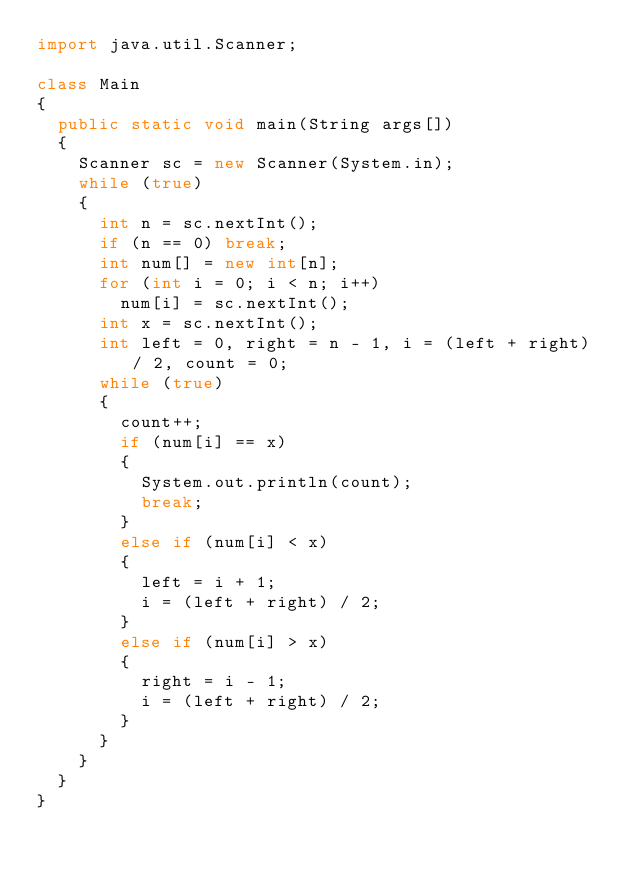<code> <loc_0><loc_0><loc_500><loc_500><_Java_>import java.util.Scanner;

class Main
{
	public static void main(String args[])
	{
		Scanner sc = new Scanner(System.in);
		while (true)
		{
			int n = sc.nextInt();
			if (n == 0) break;
			int num[] = new int[n];
			for (int i = 0; i < n; i++)
				num[i] = sc.nextInt();
			int x = sc.nextInt();
			int left = 0, right = n - 1, i = (left + right) / 2, count = 0;
			while (true)
			{
				count++;
				if (num[i] == x)
				{
					System.out.println(count);
					break;
				}
				else if (num[i] < x)
				{
					left = i + 1;
					i = (left + right) / 2;
				}
				else if (num[i] > x)
				{
					right = i - 1;
					i = (left + right) / 2;
				}
			}
		}
	}
}</code> 